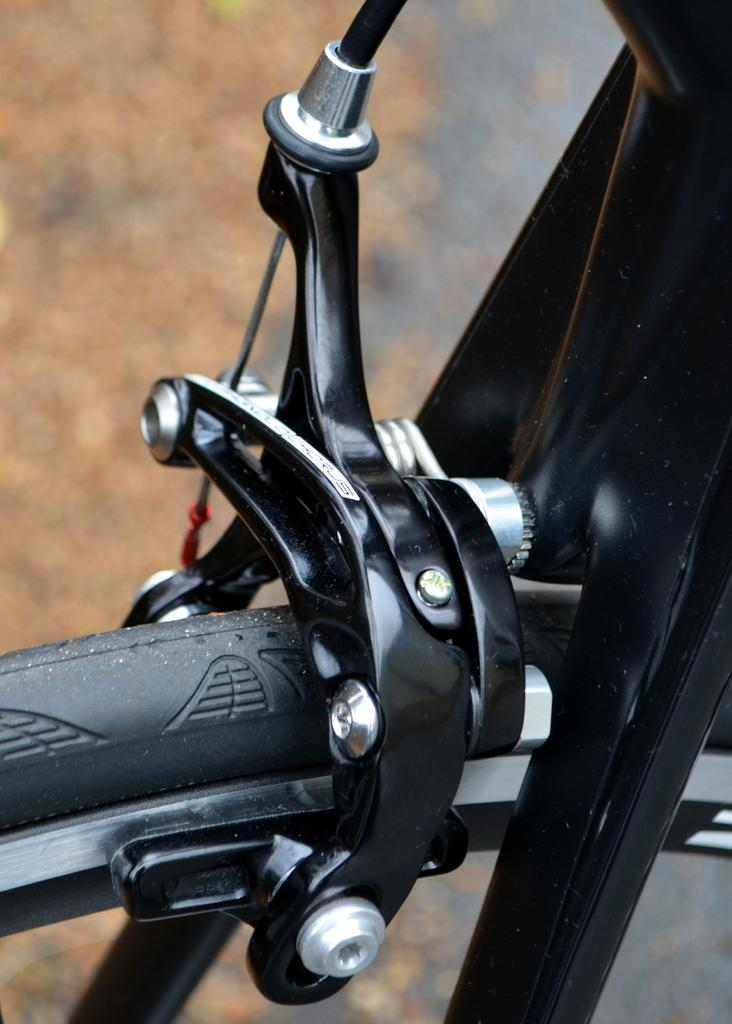What is the main object in the image? There is a bicycle in the image. Can you describe a specific part of the bicycle? The break part of the bicycle is visible. How would you describe the background of the image? The background of the image is blurred. What degree of shame is the bicycle feeling in the image? Bicycles do not experience emotions like shame, so this question cannot be answered. 